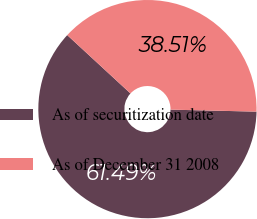<chart> <loc_0><loc_0><loc_500><loc_500><pie_chart><fcel>As of securitization date<fcel>As of December 31 2008<nl><fcel>61.49%<fcel>38.51%<nl></chart> 